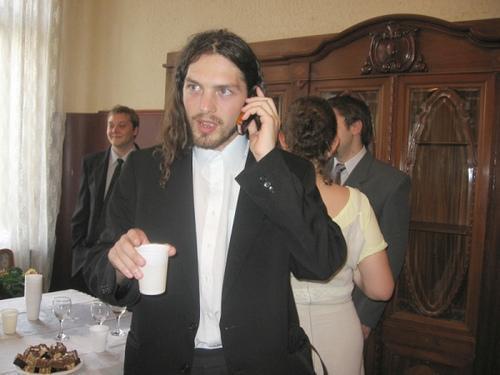How many people are in the picture?
Give a very brief answer. 4. 